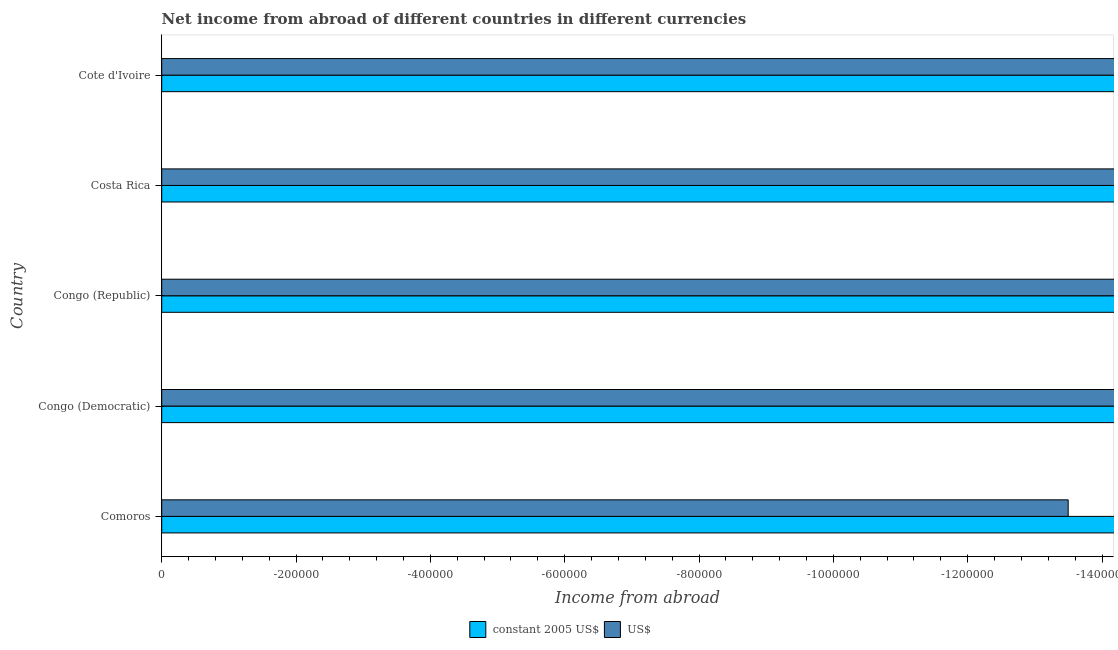How many different coloured bars are there?
Keep it short and to the point. 0. Are the number of bars on each tick of the Y-axis equal?
Give a very brief answer. Yes. How many bars are there on the 4th tick from the top?
Make the answer very short. 0. What is the label of the 4th group of bars from the top?
Your answer should be compact. Congo (Democratic). In how many cases, is the number of bars for a given country not equal to the number of legend labels?
Your answer should be compact. 5. What is the total income from abroad in constant 2005 us$ in the graph?
Provide a succinct answer. 0. What is the average income from abroad in constant 2005 us$ per country?
Your answer should be compact. 0. In how many countries, is the income from abroad in us$ greater than -1200000 units?
Your answer should be very brief. 0. How many bars are there?
Ensure brevity in your answer.  0. Are the values on the major ticks of X-axis written in scientific E-notation?
Make the answer very short. No. Does the graph contain any zero values?
Offer a terse response. Yes. Where does the legend appear in the graph?
Provide a succinct answer. Bottom center. What is the title of the graph?
Ensure brevity in your answer.  Net income from abroad of different countries in different currencies. What is the label or title of the X-axis?
Ensure brevity in your answer.  Income from abroad. What is the Income from abroad in constant 2005 US$ in Comoros?
Offer a terse response. 0. What is the Income from abroad in US$ in Comoros?
Offer a terse response. 0. What is the Income from abroad of constant 2005 US$ in Congo (Republic)?
Your answer should be very brief. 0. What is the average Income from abroad of constant 2005 US$ per country?
Offer a terse response. 0. 